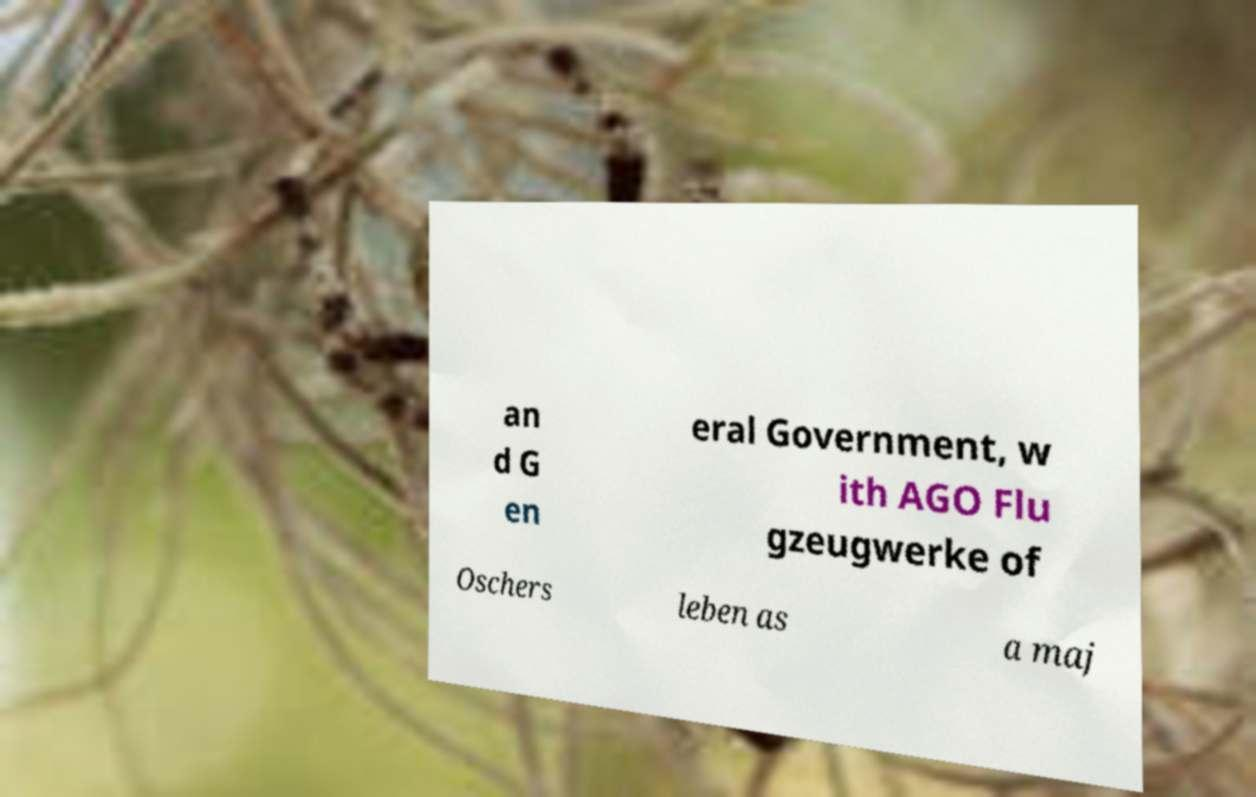There's text embedded in this image that I need extracted. Can you transcribe it verbatim? an d G en eral Government, w ith AGO Flu gzeugwerke of Oschers leben as a maj 